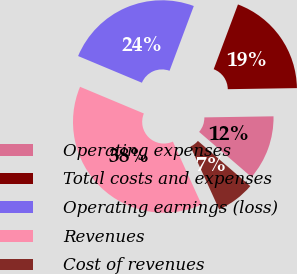Convert chart. <chart><loc_0><loc_0><loc_500><loc_500><pie_chart><fcel>Operating expenses<fcel>Total costs and expenses<fcel>Operating earnings (loss)<fcel>Revenues<fcel>Cost of revenues<nl><fcel>11.57%<fcel>19.05%<fcel>24.4%<fcel>38.12%<fcel>6.87%<nl></chart> 